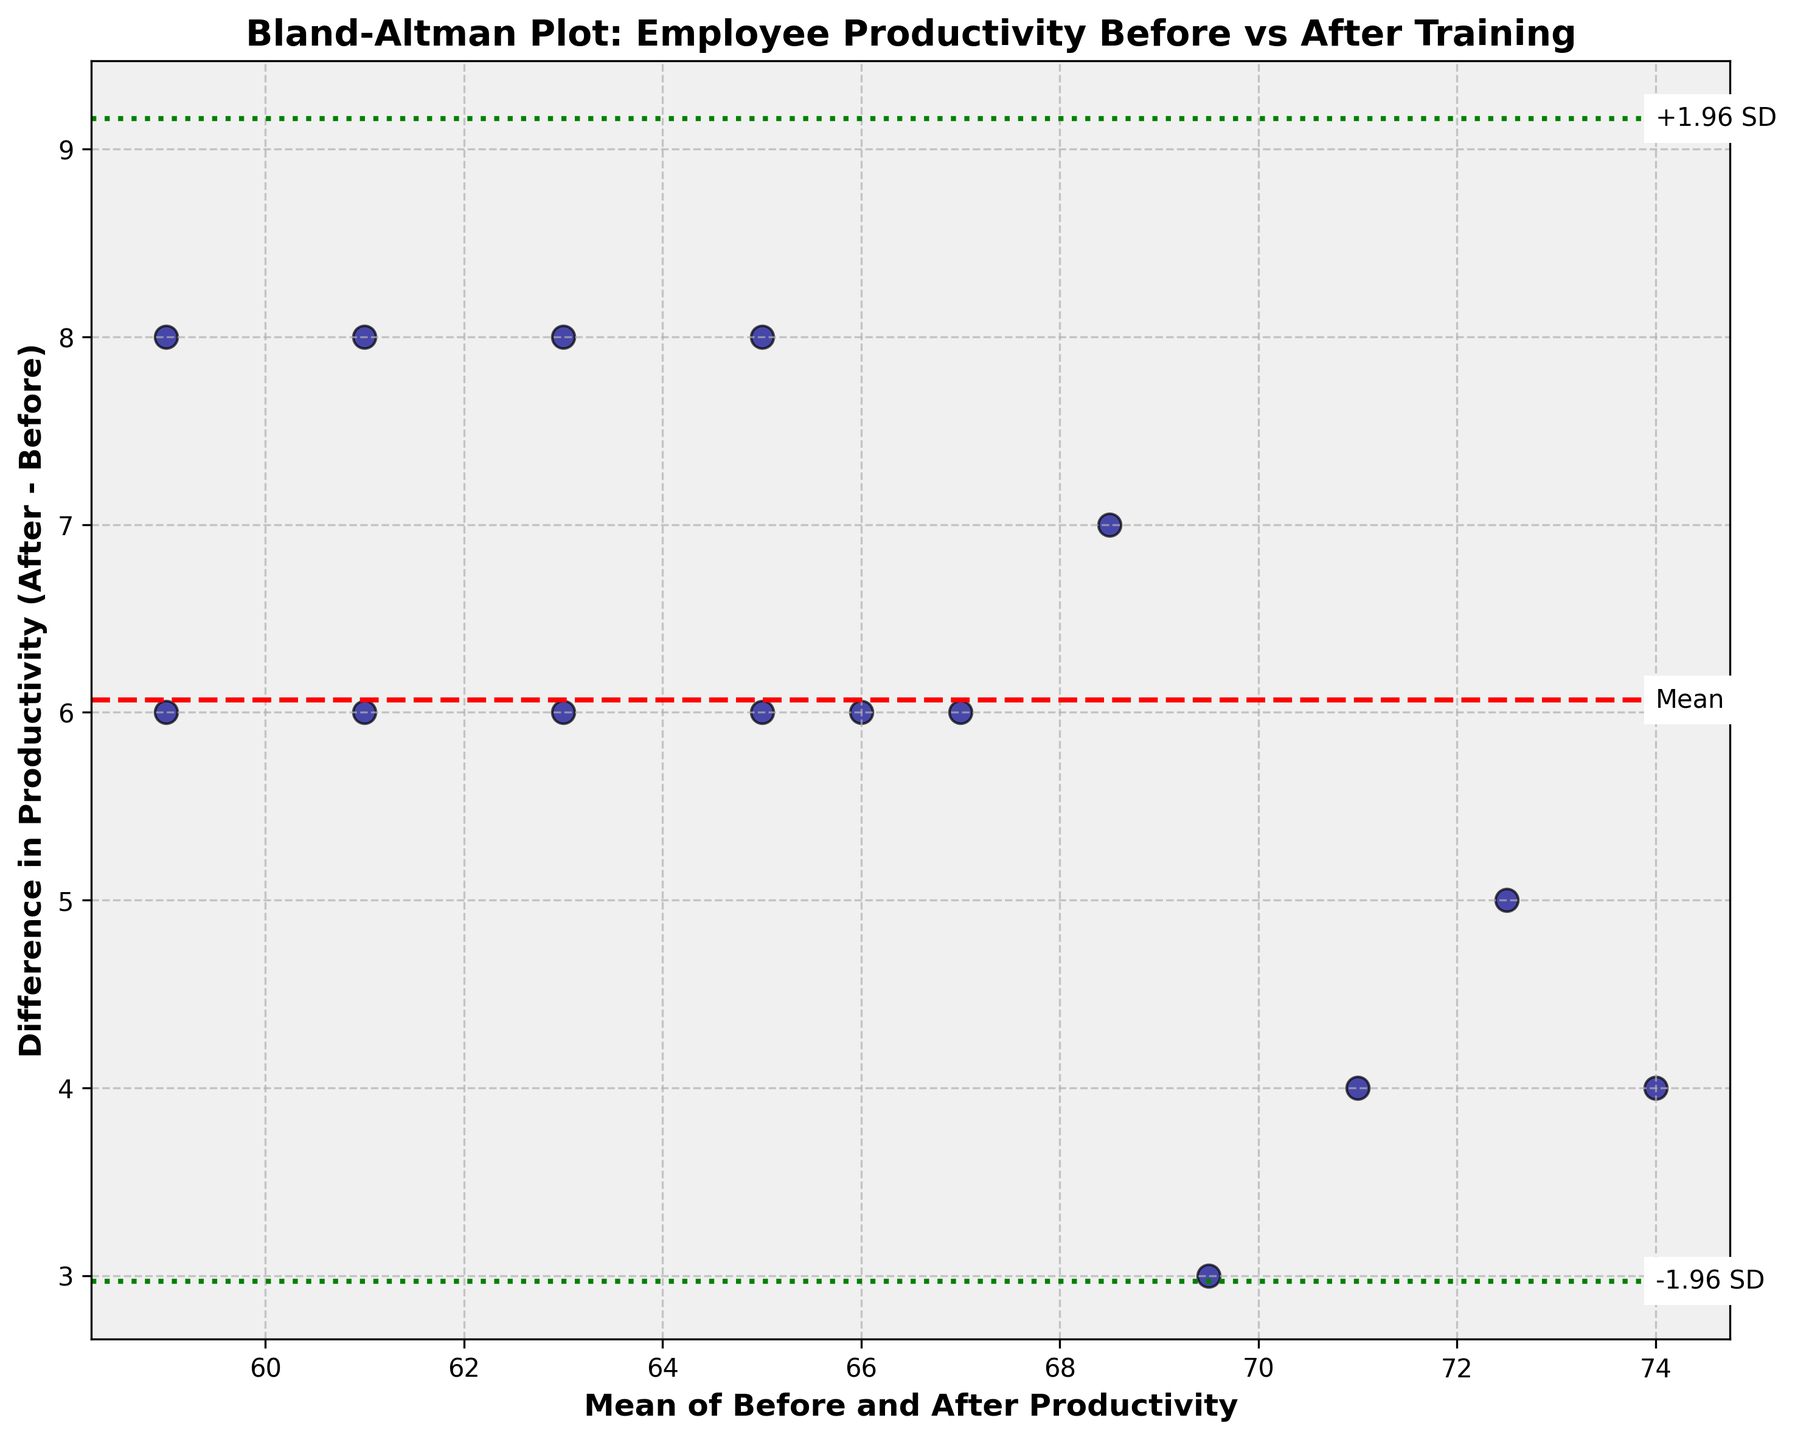What is the title of the figure? The title is provided at the top of the figure. It reads "Bland-Altman Plot: Employee Productivity Before vs After Training."
Answer: Bland-Altman Plot: Employee Productivity Before vs After Training What is represented on the x-axis? The x-axis label is "Mean of Before and After Productivity." This represents the average productivity of each employee before and after the training program.
Answer: Mean of Before and After Productivity How many data points are shown in the figure? There are 15 data points, each corresponding to one employee. The number of employees from the dataset is 15, thus there are 15 points on the plot.
Answer: 15 What does the red dashed line in the figure represent? The red dashed line is centered horizontally on the y-axis and indicates the mean difference in productivity between before and after the training. This mean is calculated by averaging all the differences.
Answer: Mean difference What is the purpose of the green dotted lines in the figure? The green dotted lines are the limits of agreement, plotted at ±1.96 standard deviations from the mean difference. These lines show the range within which most differences between before and after productivity should lie.
Answer: Limits of agreement Are there any data points outside the limits of agreement? By observing the plot, we can see that no data points fall outside the green dotted lines representing the limits of agreement. All data points are within the range.
Answer: No Which employee has the highest average productivity between before and after training? The x-axis represents the mean productivity. By identifying the furthest data point to the right on the x-axis, we can see that Amanda Patel has the highest average productivity.
Answer: Amanda Patel What is the mean of the before and after productivity for John Smith? John Smith’s before and after productivity values are 65 and 72, respectively. The mean is calculated as (65 + 72) / 2 = 137 / 2 = 68.5.
Answer: 68.5 Does the mean difference line indicate an increase or decrease in productivity after the training? The red dashed line, representing the mean difference, is above the zero line on the y-axis, suggesting that, on average, productivity increased after the training program.
Answer: Increase What is the difference in productivity for Daniel Kim? Daniel Kim’s productivity values before and after training are 64 and 70, respectively. The difference is calculated as 70 - 64 = 6.
Answer: 6 